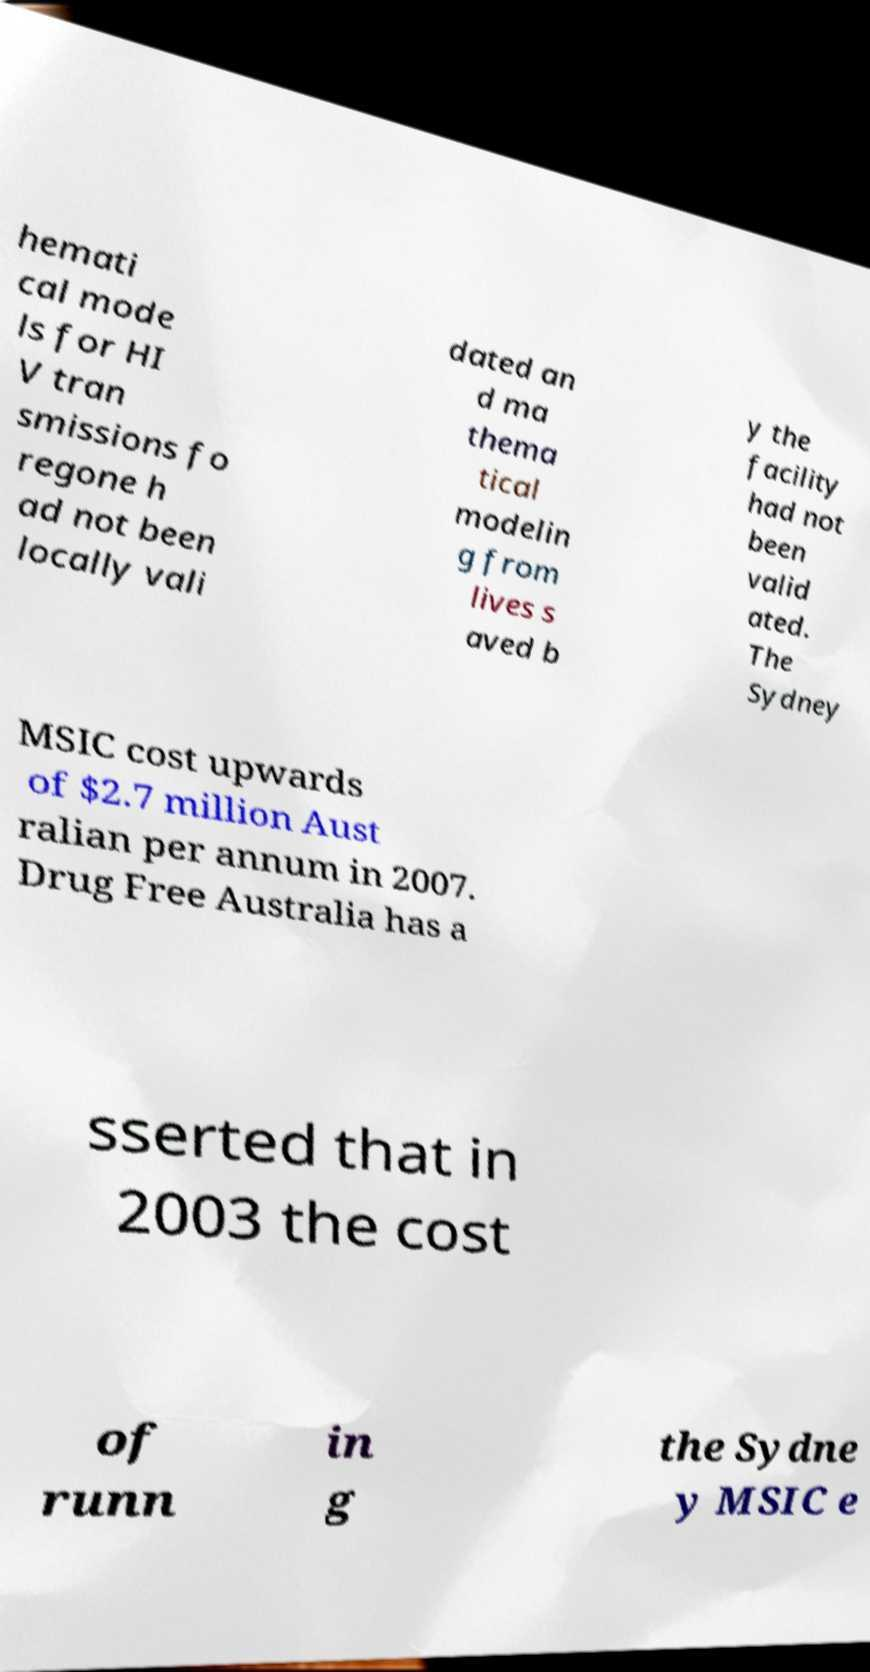For documentation purposes, I need the text within this image transcribed. Could you provide that? hemati cal mode ls for HI V tran smissions fo regone h ad not been locally vali dated an d ma thema tical modelin g from lives s aved b y the facility had not been valid ated. The Sydney MSIC cost upwards of $2.7 million Aust ralian per annum in 2007. Drug Free Australia has a sserted that in 2003 the cost of runn in g the Sydne y MSIC e 